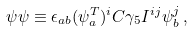Convert formula to latex. <formula><loc_0><loc_0><loc_500><loc_500>\psi \psi \equiv \epsilon _ { a b } ( \psi _ { a } ^ { T } ) ^ { i } C \gamma _ { 5 } I ^ { i j } \psi _ { b } ^ { j } \, ,</formula> 